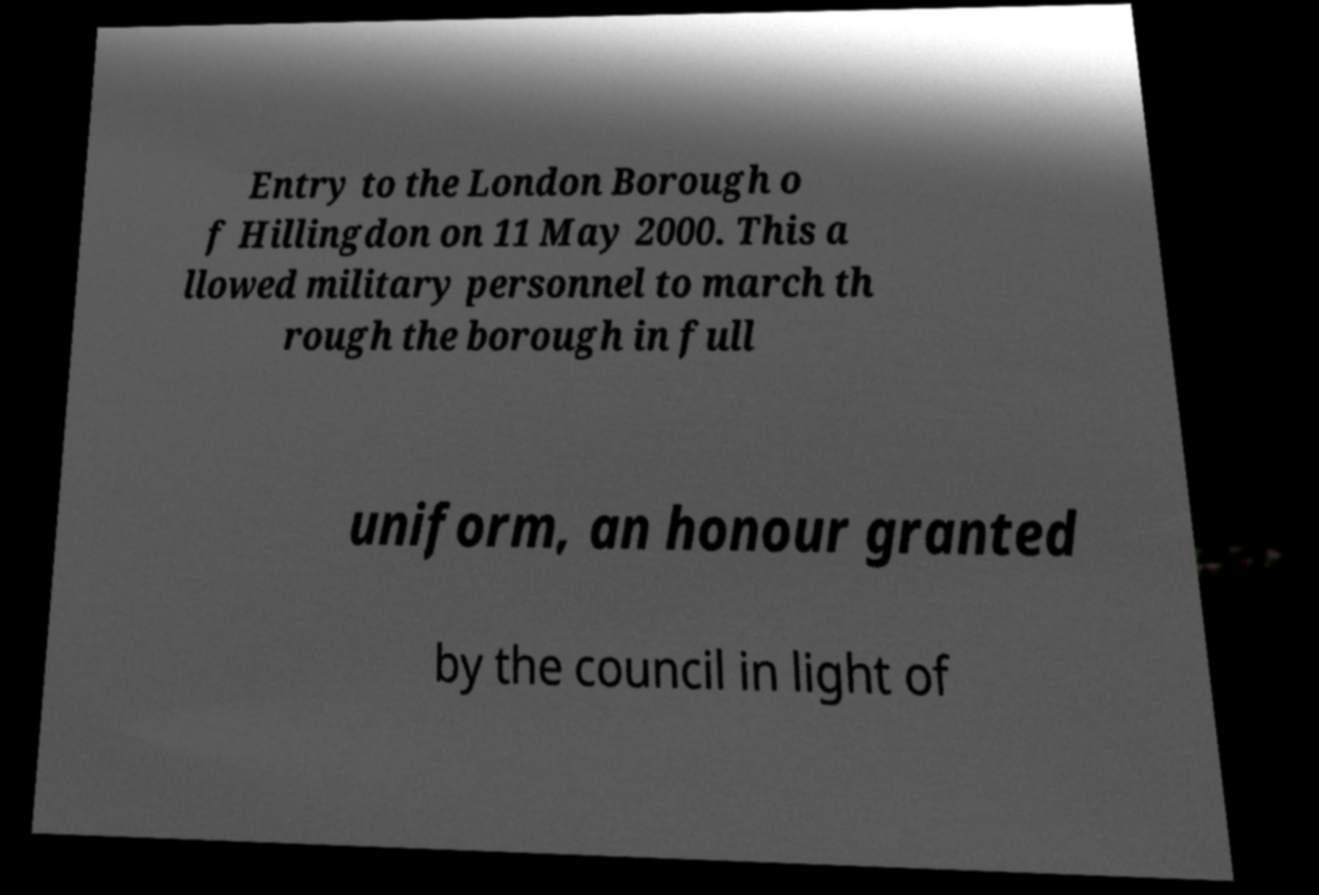Can you read and provide the text displayed in the image?This photo seems to have some interesting text. Can you extract and type it out for me? Entry to the London Borough o f Hillingdon on 11 May 2000. This a llowed military personnel to march th rough the borough in full uniform, an honour granted by the council in light of 